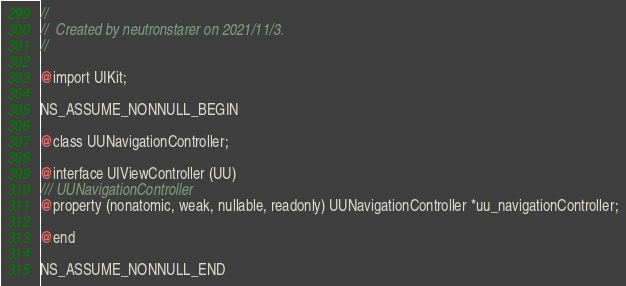Convert code to text. <code><loc_0><loc_0><loc_500><loc_500><_C_>//
//  Created by neutronstarer on 2021/11/3.
//

@import UIKit;

NS_ASSUME_NONNULL_BEGIN

@class UUNavigationController;

@interface UIViewController (UU)
/// UUNavigationController
@property (nonatomic, weak, nullable, readonly) UUNavigationController *uu_navigationController;

@end

NS_ASSUME_NONNULL_END
</code> 